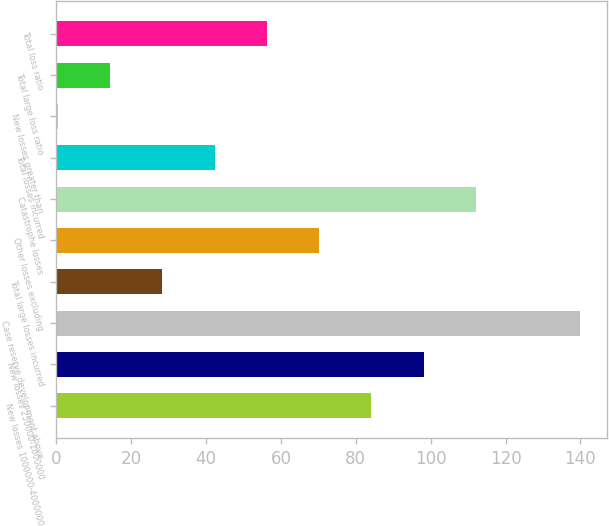Convert chart to OTSL. <chart><loc_0><loc_0><loc_500><loc_500><bar_chart><fcel>New losses 1000000-4000000<fcel>New losses 250000-1000000<fcel>Case reserve development above<fcel>Total large losses incurred<fcel>Other losses excluding<fcel>Catastrophe losses<fcel>Total losses incurred<fcel>New losses greater than<fcel>Total large loss ratio<fcel>Total loss ratio<nl><fcel>84.17<fcel>98.13<fcel>140<fcel>28.33<fcel>70.21<fcel>112.09<fcel>42.29<fcel>0.41<fcel>14.37<fcel>56.25<nl></chart> 